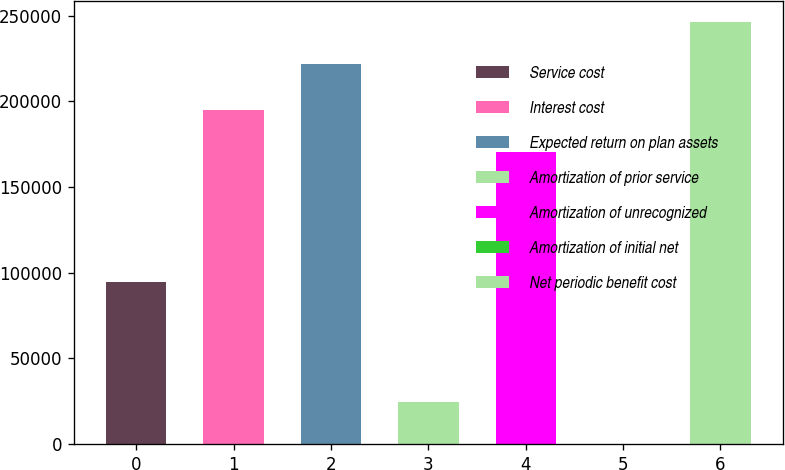<chart> <loc_0><loc_0><loc_500><loc_500><bar_chart><fcel>Service cost<fcel>Interest cost<fcel>Expected return on plan assets<fcel>Amortization of prior service<fcel>Amortization of unrecognized<fcel>Amortization of initial net<fcel>Net periodic benefit cost<nl><fcel>94650<fcel>194863<fcel>221629<fcel>24472.7<fcel>170407<fcel>17<fcel>246085<nl></chart> 